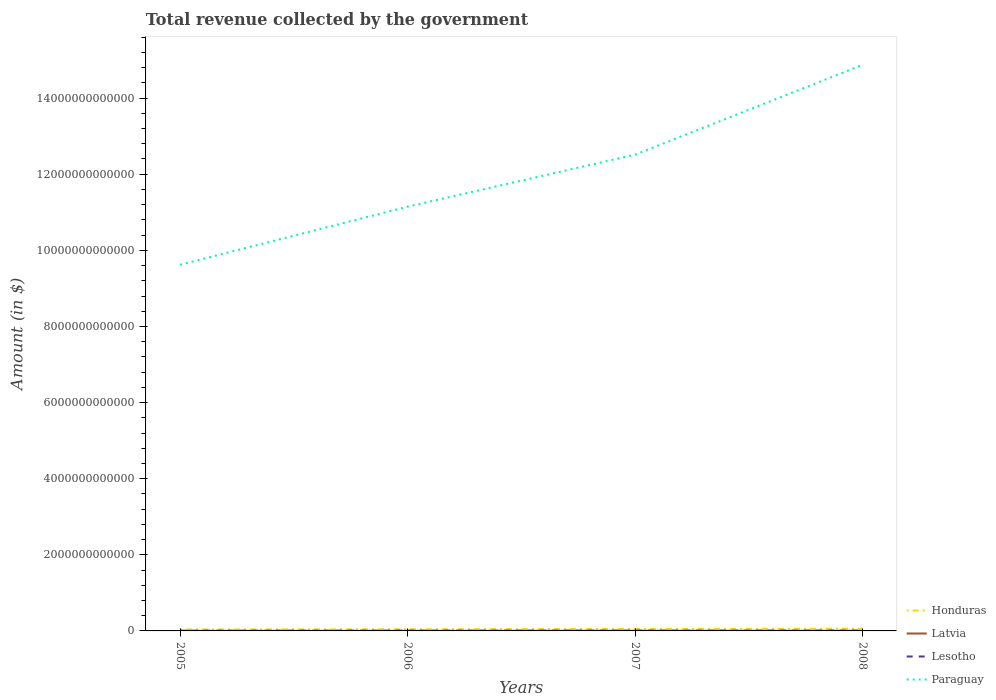Is the number of lines equal to the number of legend labels?
Make the answer very short. Yes. Across all years, what is the maximum total revenue collected by the government in Latvia?
Offer a very short reply. 2.38e+09. In which year was the total revenue collected by the government in Lesotho maximum?
Provide a succinct answer. 2005. What is the total total revenue collected by the government in Lesotho in the graph?
Give a very brief answer. -6.38e+08. What is the difference between the highest and the second highest total revenue collected by the government in Latvia?
Offer a terse response. 1.85e+09. What is the difference between the highest and the lowest total revenue collected by the government in Paraguay?
Provide a succinct answer. 2. How many lines are there?
Offer a very short reply. 4. How many years are there in the graph?
Your answer should be very brief. 4. What is the difference between two consecutive major ticks on the Y-axis?
Keep it short and to the point. 2.00e+12. Are the values on the major ticks of Y-axis written in scientific E-notation?
Give a very brief answer. No. Does the graph contain grids?
Provide a short and direct response. No. Where does the legend appear in the graph?
Keep it short and to the point. Bottom right. What is the title of the graph?
Give a very brief answer. Total revenue collected by the government. Does "Indonesia" appear as one of the legend labels in the graph?
Provide a short and direct response. No. What is the label or title of the X-axis?
Keep it short and to the point. Years. What is the label or title of the Y-axis?
Offer a terse response. Amount (in $). What is the Amount (in $) in Honduras in 2005?
Give a very brief answer. 3.81e+1. What is the Amount (in $) of Latvia in 2005?
Your answer should be very brief. 2.38e+09. What is the Amount (in $) of Lesotho in 2005?
Your response must be concise. 4.53e+09. What is the Amount (in $) of Paraguay in 2005?
Provide a short and direct response. 9.62e+12. What is the Amount (in $) in Honduras in 2006?
Ensure brevity in your answer.  4.35e+1. What is the Amount (in $) in Latvia in 2006?
Offer a terse response. 3.04e+09. What is the Amount (in $) in Lesotho in 2006?
Give a very brief answer. 6.49e+09. What is the Amount (in $) of Paraguay in 2006?
Offer a terse response. 1.11e+13. What is the Amount (in $) in Honduras in 2007?
Give a very brief answer. 5.15e+1. What is the Amount (in $) in Latvia in 2007?
Your answer should be very brief. 3.93e+09. What is the Amount (in $) in Lesotho in 2007?
Give a very brief answer. 7.13e+09. What is the Amount (in $) of Paraguay in 2007?
Your answer should be very brief. 1.25e+13. What is the Amount (in $) of Honduras in 2008?
Ensure brevity in your answer.  5.97e+1. What is the Amount (in $) of Latvia in 2008?
Your answer should be compact. 4.23e+09. What is the Amount (in $) of Lesotho in 2008?
Make the answer very short. 8.76e+09. What is the Amount (in $) of Paraguay in 2008?
Keep it short and to the point. 1.49e+13. Across all years, what is the maximum Amount (in $) in Honduras?
Your answer should be compact. 5.97e+1. Across all years, what is the maximum Amount (in $) of Latvia?
Your answer should be very brief. 4.23e+09. Across all years, what is the maximum Amount (in $) in Lesotho?
Provide a short and direct response. 8.76e+09. Across all years, what is the maximum Amount (in $) in Paraguay?
Your answer should be very brief. 1.49e+13. Across all years, what is the minimum Amount (in $) in Honduras?
Provide a short and direct response. 3.81e+1. Across all years, what is the minimum Amount (in $) in Latvia?
Your answer should be compact. 2.38e+09. Across all years, what is the minimum Amount (in $) in Lesotho?
Your answer should be compact. 4.53e+09. Across all years, what is the minimum Amount (in $) of Paraguay?
Provide a short and direct response. 9.62e+12. What is the total Amount (in $) of Honduras in the graph?
Make the answer very short. 1.93e+11. What is the total Amount (in $) in Latvia in the graph?
Give a very brief answer. 1.36e+1. What is the total Amount (in $) of Lesotho in the graph?
Your response must be concise. 2.69e+1. What is the total Amount (in $) of Paraguay in the graph?
Provide a short and direct response. 4.82e+13. What is the difference between the Amount (in $) in Honduras in 2005 and that in 2006?
Your response must be concise. -5.42e+09. What is the difference between the Amount (in $) in Latvia in 2005 and that in 2006?
Provide a succinct answer. -6.58e+08. What is the difference between the Amount (in $) of Lesotho in 2005 and that in 2006?
Your response must be concise. -1.95e+09. What is the difference between the Amount (in $) in Paraguay in 2005 and that in 2006?
Keep it short and to the point. -1.53e+12. What is the difference between the Amount (in $) of Honduras in 2005 and that in 2007?
Give a very brief answer. -1.34e+1. What is the difference between the Amount (in $) in Latvia in 2005 and that in 2007?
Your response must be concise. -1.55e+09. What is the difference between the Amount (in $) of Lesotho in 2005 and that in 2007?
Your answer should be very brief. -2.59e+09. What is the difference between the Amount (in $) in Paraguay in 2005 and that in 2007?
Your answer should be compact. -2.89e+12. What is the difference between the Amount (in $) of Honduras in 2005 and that in 2008?
Ensure brevity in your answer.  -2.16e+1. What is the difference between the Amount (in $) of Latvia in 2005 and that in 2008?
Your answer should be very brief. -1.85e+09. What is the difference between the Amount (in $) in Lesotho in 2005 and that in 2008?
Provide a short and direct response. -4.22e+09. What is the difference between the Amount (in $) of Paraguay in 2005 and that in 2008?
Keep it short and to the point. -5.25e+12. What is the difference between the Amount (in $) of Honduras in 2006 and that in 2007?
Give a very brief answer. -7.99e+09. What is the difference between the Amount (in $) in Latvia in 2006 and that in 2007?
Provide a short and direct response. -8.90e+08. What is the difference between the Amount (in $) in Lesotho in 2006 and that in 2007?
Provide a succinct answer. -6.38e+08. What is the difference between the Amount (in $) of Paraguay in 2006 and that in 2007?
Your response must be concise. -1.37e+12. What is the difference between the Amount (in $) of Honduras in 2006 and that in 2008?
Give a very brief answer. -1.61e+1. What is the difference between the Amount (in $) in Latvia in 2006 and that in 2008?
Provide a succinct answer. -1.19e+09. What is the difference between the Amount (in $) in Lesotho in 2006 and that in 2008?
Provide a short and direct response. -2.27e+09. What is the difference between the Amount (in $) in Paraguay in 2006 and that in 2008?
Provide a succinct answer. -3.73e+12. What is the difference between the Amount (in $) in Honduras in 2007 and that in 2008?
Provide a short and direct response. -8.15e+09. What is the difference between the Amount (in $) of Latvia in 2007 and that in 2008?
Your response must be concise. -2.99e+08. What is the difference between the Amount (in $) of Lesotho in 2007 and that in 2008?
Offer a very short reply. -1.63e+09. What is the difference between the Amount (in $) of Paraguay in 2007 and that in 2008?
Keep it short and to the point. -2.36e+12. What is the difference between the Amount (in $) in Honduras in 2005 and the Amount (in $) in Latvia in 2006?
Offer a terse response. 3.51e+1. What is the difference between the Amount (in $) of Honduras in 2005 and the Amount (in $) of Lesotho in 2006?
Your response must be concise. 3.16e+1. What is the difference between the Amount (in $) of Honduras in 2005 and the Amount (in $) of Paraguay in 2006?
Your response must be concise. -1.11e+13. What is the difference between the Amount (in $) of Latvia in 2005 and the Amount (in $) of Lesotho in 2006?
Offer a terse response. -4.11e+09. What is the difference between the Amount (in $) in Latvia in 2005 and the Amount (in $) in Paraguay in 2006?
Give a very brief answer. -1.11e+13. What is the difference between the Amount (in $) of Lesotho in 2005 and the Amount (in $) of Paraguay in 2006?
Provide a short and direct response. -1.11e+13. What is the difference between the Amount (in $) of Honduras in 2005 and the Amount (in $) of Latvia in 2007?
Your answer should be compact. 3.42e+1. What is the difference between the Amount (in $) in Honduras in 2005 and the Amount (in $) in Lesotho in 2007?
Your response must be concise. 3.10e+1. What is the difference between the Amount (in $) of Honduras in 2005 and the Amount (in $) of Paraguay in 2007?
Provide a succinct answer. -1.25e+13. What is the difference between the Amount (in $) in Latvia in 2005 and the Amount (in $) in Lesotho in 2007?
Provide a succinct answer. -4.75e+09. What is the difference between the Amount (in $) in Latvia in 2005 and the Amount (in $) in Paraguay in 2007?
Your answer should be very brief. -1.25e+13. What is the difference between the Amount (in $) of Lesotho in 2005 and the Amount (in $) of Paraguay in 2007?
Make the answer very short. -1.25e+13. What is the difference between the Amount (in $) in Honduras in 2005 and the Amount (in $) in Latvia in 2008?
Provide a succinct answer. 3.39e+1. What is the difference between the Amount (in $) of Honduras in 2005 and the Amount (in $) of Lesotho in 2008?
Provide a succinct answer. 2.94e+1. What is the difference between the Amount (in $) in Honduras in 2005 and the Amount (in $) in Paraguay in 2008?
Keep it short and to the point. -1.48e+13. What is the difference between the Amount (in $) in Latvia in 2005 and the Amount (in $) in Lesotho in 2008?
Provide a succinct answer. -6.38e+09. What is the difference between the Amount (in $) of Latvia in 2005 and the Amount (in $) of Paraguay in 2008?
Provide a short and direct response. -1.49e+13. What is the difference between the Amount (in $) in Lesotho in 2005 and the Amount (in $) in Paraguay in 2008?
Ensure brevity in your answer.  -1.49e+13. What is the difference between the Amount (in $) of Honduras in 2006 and the Amount (in $) of Latvia in 2007?
Ensure brevity in your answer.  3.96e+1. What is the difference between the Amount (in $) in Honduras in 2006 and the Amount (in $) in Lesotho in 2007?
Offer a very short reply. 3.64e+1. What is the difference between the Amount (in $) of Honduras in 2006 and the Amount (in $) of Paraguay in 2007?
Provide a short and direct response. -1.25e+13. What is the difference between the Amount (in $) in Latvia in 2006 and the Amount (in $) in Lesotho in 2007?
Give a very brief answer. -4.09e+09. What is the difference between the Amount (in $) of Latvia in 2006 and the Amount (in $) of Paraguay in 2007?
Make the answer very short. -1.25e+13. What is the difference between the Amount (in $) in Lesotho in 2006 and the Amount (in $) in Paraguay in 2007?
Your answer should be very brief. -1.25e+13. What is the difference between the Amount (in $) in Honduras in 2006 and the Amount (in $) in Latvia in 2008?
Make the answer very short. 3.93e+1. What is the difference between the Amount (in $) in Honduras in 2006 and the Amount (in $) in Lesotho in 2008?
Provide a succinct answer. 3.48e+1. What is the difference between the Amount (in $) of Honduras in 2006 and the Amount (in $) of Paraguay in 2008?
Provide a short and direct response. -1.48e+13. What is the difference between the Amount (in $) in Latvia in 2006 and the Amount (in $) in Lesotho in 2008?
Your answer should be very brief. -5.72e+09. What is the difference between the Amount (in $) in Latvia in 2006 and the Amount (in $) in Paraguay in 2008?
Ensure brevity in your answer.  -1.49e+13. What is the difference between the Amount (in $) in Lesotho in 2006 and the Amount (in $) in Paraguay in 2008?
Offer a very short reply. -1.49e+13. What is the difference between the Amount (in $) in Honduras in 2007 and the Amount (in $) in Latvia in 2008?
Give a very brief answer. 4.73e+1. What is the difference between the Amount (in $) of Honduras in 2007 and the Amount (in $) of Lesotho in 2008?
Your answer should be very brief. 4.28e+1. What is the difference between the Amount (in $) of Honduras in 2007 and the Amount (in $) of Paraguay in 2008?
Offer a very short reply. -1.48e+13. What is the difference between the Amount (in $) of Latvia in 2007 and the Amount (in $) of Lesotho in 2008?
Offer a terse response. -4.83e+09. What is the difference between the Amount (in $) of Latvia in 2007 and the Amount (in $) of Paraguay in 2008?
Your answer should be compact. -1.49e+13. What is the difference between the Amount (in $) in Lesotho in 2007 and the Amount (in $) in Paraguay in 2008?
Offer a very short reply. -1.49e+13. What is the average Amount (in $) in Honduras per year?
Provide a short and direct response. 4.82e+1. What is the average Amount (in $) in Latvia per year?
Ensure brevity in your answer.  3.39e+09. What is the average Amount (in $) of Lesotho per year?
Give a very brief answer. 6.73e+09. What is the average Amount (in $) in Paraguay per year?
Give a very brief answer. 1.20e+13. In the year 2005, what is the difference between the Amount (in $) of Honduras and Amount (in $) of Latvia?
Provide a short and direct response. 3.57e+1. In the year 2005, what is the difference between the Amount (in $) of Honduras and Amount (in $) of Lesotho?
Your response must be concise. 3.36e+1. In the year 2005, what is the difference between the Amount (in $) of Honduras and Amount (in $) of Paraguay?
Offer a terse response. -9.58e+12. In the year 2005, what is the difference between the Amount (in $) of Latvia and Amount (in $) of Lesotho?
Your answer should be very brief. -2.15e+09. In the year 2005, what is the difference between the Amount (in $) of Latvia and Amount (in $) of Paraguay?
Your response must be concise. -9.62e+12. In the year 2005, what is the difference between the Amount (in $) in Lesotho and Amount (in $) in Paraguay?
Your answer should be compact. -9.62e+12. In the year 2006, what is the difference between the Amount (in $) in Honduras and Amount (in $) in Latvia?
Ensure brevity in your answer.  4.05e+1. In the year 2006, what is the difference between the Amount (in $) of Honduras and Amount (in $) of Lesotho?
Ensure brevity in your answer.  3.71e+1. In the year 2006, what is the difference between the Amount (in $) of Honduras and Amount (in $) of Paraguay?
Provide a short and direct response. -1.11e+13. In the year 2006, what is the difference between the Amount (in $) of Latvia and Amount (in $) of Lesotho?
Your answer should be compact. -3.45e+09. In the year 2006, what is the difference between the Amount (in $) in Latvia and Amount (in $) in Paraguay?
Your answer should be very brief. -1.11e+13. In the year 2006, what is the difference between the Amount (in $) in Lesotho and Amount (in $) in Paraguay?
Offer a very short reply. -1.11e+13. In the year 2007, what is the difference between the Amount (in $) in Honduras and Amount (in $) in Latvia?
Your answer should be very brief. 4.76e+1. In the year 2007, what is the difference between the Amount (in $) of Honduras and Amount (in $) of Lesotho?
Your response must be concise. 4.44e+1. In the year 2007, what is the difference between the Amount (in $) of Honduras and Amount (in $) of Paraguay?
Provide a succinct answer. -1.25e+13. In the year 2007, what is the difference between the Amount (in $) in Latvia and Amount (in $) in Lesotho?
Provide a short and direct response. -3.20e+09. In the year 2007, what is the difference between the Amount (in $) of Latvia and Amount (in $) of Paraguay?
Ensure brevity in your answer.  -1.25e+13. In the year 2007, what is the difference between the Amount (in $) of Lesotho and Amount (in $) of Paraguay?
Your answer should be very brief. -1.25e+13. In the year 2008, what is the difference between the Amount (in $) of Honduras and Amount (in $) of Latvia?
Keep it short and to the point. 5.55e+1. In the year 2008, what is the difference between the Amount (in $) in Honduras and Amount (in $) in Lesotho?
Provide a succinct answer. 5.09e+1. In the year 2008, what is the difference between the Amount (in $) in Honduras and Amount (in $) in Paraguay?
Provide a succinct answer. -1.48e+13. In the year 2008, what is the difference between the Amount (in $) in Latvia and Amount (in $) in Lesotho?
Your response must be concise. -4.53e+09. In the year 2008, what is the difference between the Amount (in $) in Latvia and Amount (in $) in Paraguay?
Ensure brevity in your answer.  -1.49e+13. In the year 2008, what is the difference between the Amount (in $) of Lesotho and Amount (in $) of Paraguay?
Offer a terse response. -1.49e+13. What is the ratio of the Amount (in $) in Honduras in 2005 to that in 2006?
Your answer should be compact. 0.88. What is the ratio of the Amount (in $) in Latvia in 2005 to that in 2006?
Your answer should be very brief. 0.78. What is the ratio of the Amount (in $) in Lesotho in 2005 to that in 2006?
Make the answer very short. 0.7. What is the ratio of the Amount (in $) in Paraguay in 2005 to that in 2006?
Provide a succinct answer. 0.86. What is the ratio of the Amount (in $) of Honduras in 2005 to that in 2007?
Keep it short and to the point. 0.74. What is the ratio of the Amount (in $) in Latvia in 2005 to that in 2007?
Make the answer very short. 0.61. What is the ratio of the Amount (in $) of Lesotho in 2005 to that in 2007?
Provide a succinct answer. 0.64. What is the ratio of the Amount (in $) in Paraguay in 2005 to that in 2007?
Keep it short and to the point. 0.77. What is the ratio of the Amount (in $) of Honduras in 2005 to that in 2008?
Offer a terse response. 0.64. What is the ratio of the Amount (in $) of Latvia in 2005 to that in 2008?
Give a very brief answer. 0.56. What is the ratio of the Amount (in $) in Lesotho in 2005 to that in 2008?
Keep it short and to the point. 0.52. What is the ratio of the Amount (in $) of Paraguay in 2005 to that in 2008?
Provide a succinct answer. 0.65. What is the ratio of the Amount (in $) of Honduras in 2006 to that in 2007?
Provide a succinct answer. 0.84. What is the ratio of the Amount (in $) of Latvia in 2006 to that in 2007?
Provide a succinct answer. 0.77. What is the ratio of the Amount (in $) of Lesotho in 2006 to that in 2007?
Offer a very short reply. 0.91. What is the ratio of the Amount (in $) of Paraguay in 2006 to that in 2007?
Your answer should be very brief. 0.89. What is the ratio of the Amount (in $) in Honduras in 2006 to that in 2008?
Provide a short and direct response. 0.73. What is the ratio of the Amount (in $) in Latvia in 2006 to that in 2008?
Offer a terse response. 0.72. What is the ratio of the Amount (in $) of Lesotho in 2006 to that in 2008?
Your answer should be very brief. 0.74. What is the ratio of the Amount (in $) of Paraguay in 2006 to that in 2008?
Provide a succinct answer. 0.75. What is the ratio of the Amount (in $) of Honduras in 2007 to that in 2008?
Provide a short and direct response. 0.86. What is the ratio of the Amount (in $) in Latvia in 2007 to that in 2008?
Your answer should be compact. 0.93. What is the ratio of the Amount (in $) of Lesotho in 2007 to that in 2008?
Offer a terse response. 0.81. What is the ratio of the Amount (in $) in Paraguay in 2007 to that in 2008?
Provide a succinct answer. 0.84. What is the difference between the highest and the second highest Amount (in $) of Honduras?
Make the answer very short. 8.15e+09. What is the difference between the highest and the second highest Amount (in $) of Latvia?
Offer a very short reply. 2.99e+08. What is the difference between the highest and the second highest Amount (in $) in Lesotho?
Your answer should be compact. 1.63e+09. What is the difference between the highest and the second highest Amount (in $) in Paraguay?
Provide a succinct answer. 2.36e+12. What is the difference between the highest and the lowest Amount (in $) of Honduras?
Give a very brief answer. 2.16e+1. What is the difference between the highest and the lowest Amount (in $) in Latvia?
Your answer should be very brief. 1.85e+09. What is the difference between the highest and the lowest Amount (in $) of Lesotho?
Your answer should be very brief. 4.22e+09. What is the difference between the highest and the lowest Amount (in $) of Paraguay?
Offer a very short reply. 5.25e+12. 